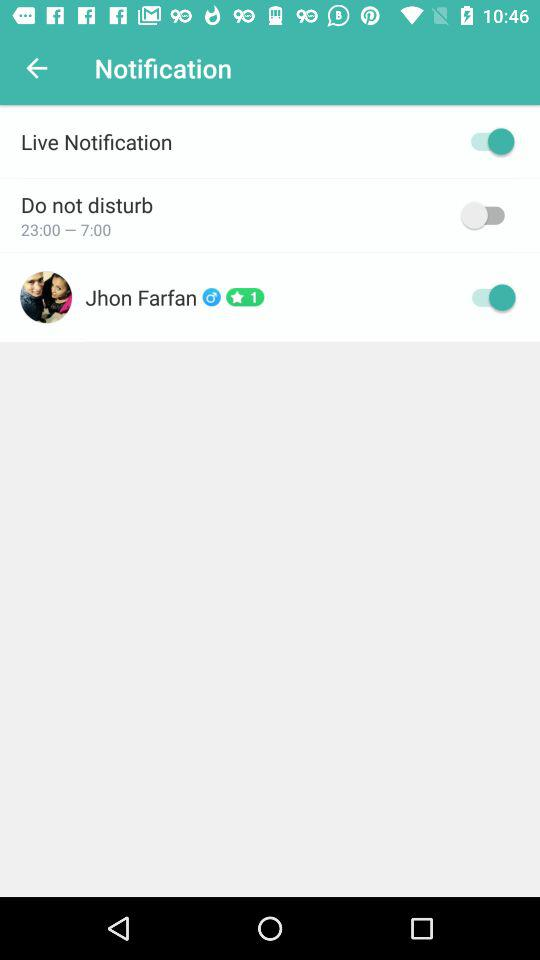What is the current status of do not disturb? The status is "on". 